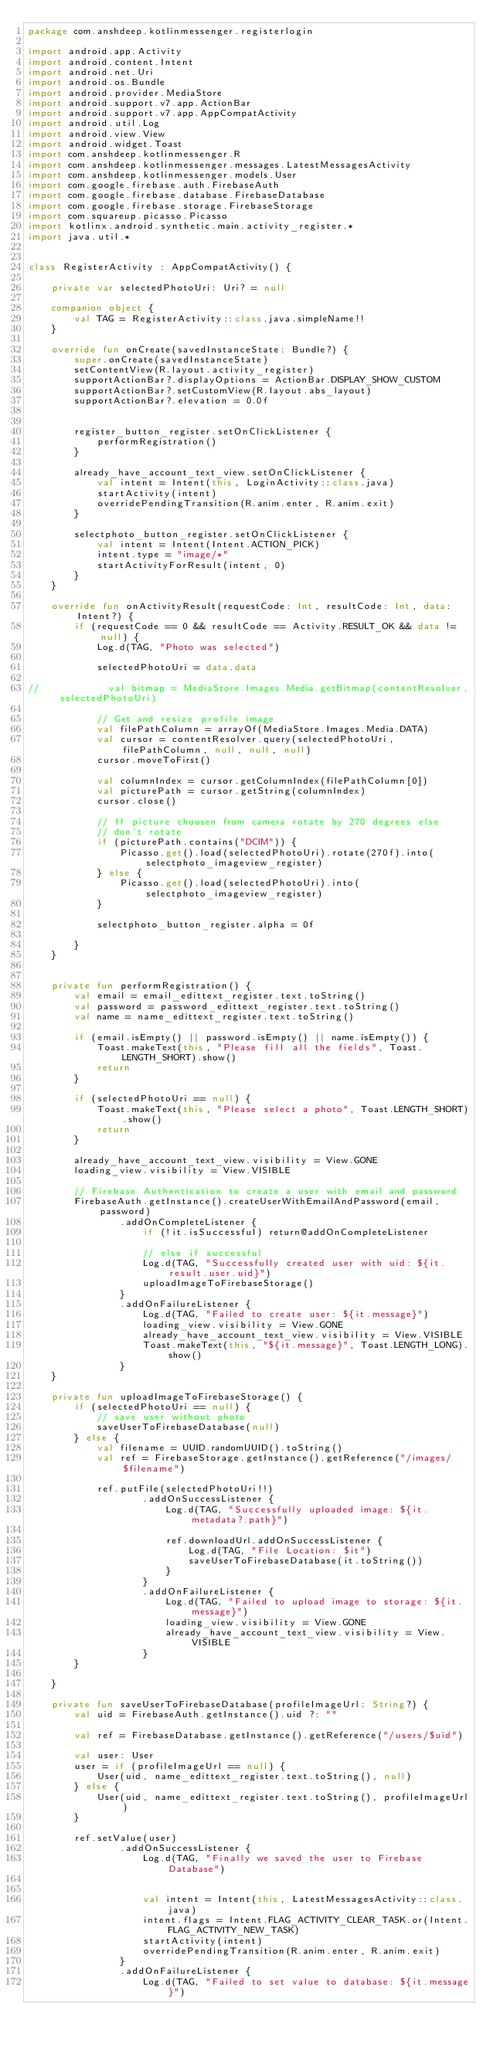<code> <loc_0><loc_0><loc_500><loc_500><_Kotlin_>package com.anshdeep.kotlinmessenger.registerlogin

import android.app.Activity
import android.content.Intent
import android.net.Uri
import android.os.Bundle
import android.provider.MediaStore
import android.support.v7.app.ActionBar
import android.support.v7.app.AppCompatActivity
import android.util.Log
import android.view.View
import android.widget.Toast
import com.anshdeep.kotlinmessenger.R
import com.anshdeep.kotlinmessenger.messages.LatestMessagesActivity
import com.anshdeep.kotlinmessenger.models.User
import com.google.firebase.auth.FirebaseAuth
import com.google.firebase.database.FirebaseDatabase
import com.google.firebase.storage.FirebaseStorage
import com.squareup.picasso.Picasso
import kotlinx.android.synthetic.main.activity_register.*
import java.util.*


class RegisterActivity : AppCompatActivity() {

    private var selectedPhotoUri: Uri? = null

    companion object {
        val TAG = RegisterActivity::class.java.simpleName!!
    }

    override fun onCreate(savedInstanceState: Bundle?) {
        super.onCreate(savedInstanceState)
        setContentView(R.layout.activity_register)
        supportActionBar?.displayOptions = ActionBar.DISPLAY_SHOW_CUSTOM
        supportActionBar?.setCustomView(R.layout.abs_layout)
        supportActionBar?.elevation = 0.0f


        register_button_register.setOnClickListener {
            performRegistration()
        }

        already_have_account_text_view.setOnClickListener {
            val intent = Intent(this, LoginActivity::class.java)
            startActivity(intent)
            overridePendingTransition(R.anim.enter, R.anim.exit)
        }

        selectphoto_button_register.setOnClickListener {
            val intent = Intent(Intent.ACTION_PICK)
            intent.type = "image/*"
            startActivityForResult(intent, 0)
        }
    }

    override fun onActivityResult(requestCode: Int, resultCode: Int, data: Intent?) {
        if (requestCode == 0 && resultCode == Activity.RESULT_OK && data != null) {
            Log.d(TAG, "Photo was selected")

            selectedPhotoUri = data.data

//            val bitmap = MediaStore.Images.Media.getBitmap(contentResolver, selectedPhotoUri)

            // Get and resize profile image
            val filePathColumn = arrayOf(MediaStore.Images.Media.DATA)
            val cursor = contentResolver.query(selectedPhotoUri, filePathColumn, null, null, null)
            cursor.moveToFirst()

            val columnIndex = cursor.getColumnIndex(filePathColumn[0])
            val picturePath = cursor.getString(columnIndex)
            cursor.close()

            // If picture choosen from camera rotate by 270 degrees else
            // don't rotate
            if (picturePath.contains("DCIM")) {
                Picasso.get().load(selectedPhotoUri).rotate(270f).into(selectphoto_imageview_register)
            } else {
                Picasso.get().load(selectedPhotoUri).into(selectphoto_imageview_register)
            }

            selectphoto_button_register.alpha = 0f

        }
    }


    private fun performRegistration() {
        val email = email_edittext_register.text.toString()
        val password = password_edittext_register.text.toString()
        val name = name_edittext_register.text.toString()

        if (email.isEmpty() || password.isEmpty() || name.isEmpty()) {
            Toast.makeText(this, "Please fill all the fields", Toast.LENGTH_SHORT).show()
            return
        }

        if (selectedPhotoUri == null) {
            Toast.makeText(this, "Please select a photo", Toast.LENGTH_SHORT).show()
            return
        }

        already_have_account_text_view.visibility = View.GONE
        loading_view.visibility = View.VISIBLE

        // Firebase Authentication to create a user with email and password
        FirebaseAuth.getInstance().createUserWithEmailAndPassword(email, password)
                .addOnCompleteListener {
                    if (!it.isSuccessful) return@addOnCompleteListener

                    // else if successful
                    Log.d(TAG, "Successfully created user with uid: ${it.result.user.uid}")
                    uploadImageToFirebaseStorage()
                }
                .addOnFailureListener {
                    Log.d(TAG, "Failed to create user: ${it.message}")
                    loading_view.visibility = View.GONE
                    already_have_account_text_view.visibility = View.VISIBLE
                    Toast.makeText(this, "${it.message}", Toast.LENGTH_LONG).show()
                }
    }

    private fun uploadImageToFirebaseStorage() {
        if (selectedPhotoUri == null) {
            // save user without photo
            saveUserToFirebaseDatabase(null)
        } else {
            val filename = UUID.randomUUID().toString()
            val ref = FirebaseStorage.getInstance().getReference("/images/$filename")

            ref.putFile(selectedPhotoUri!!)
                    .addOnSuccessListener {
                        Log.d(TAG, "Successfully uploaded image: ${it.metadata?.path}")

                        ref.downloadUrl.addOnSuccessListener {
                            Log.d(TAG, "File Location: $it")
                            saveUserToFirebaseDatabase(it.toString())
                        }
                    }
                    .addOnFailureListener {
                        Log.d(TAG, "Failed to upload image to storage: ${it.message}")
                        loading_view.visibility = View.GONE
                        already_have_account_text_view.visibility = View.VISIBLE
                    }
        }

    }

    private fun saveUserToFirebaseDatabase(profileImageUrl: String?) {
        val uid = FirebaseAuth.getInstance().uid ?: ""

        val ref = FirebaseDatabase.getInstance().getReference("/users/$uid")

        val user: User
        user = if (profileImageUrl == null) {
            User(uid, name_edittext_register.text.toString(), null)
        } else {
            User(uid, name_edittext_register.text.toString(), profileImageUrl)
        }

        ref.setValue(user)
                .addOnSuccessListener {
                    Log.d(TAG, "Finally we saved the user to Firebase Database")


                    val intent = Intent(this, LatestMessagesActivity::class.java)
                    intent.flags = Intent.FLAG_ACTIVITY_CLEAR_TASK.or(Intent.FLAG_ACTIVITY_NEW_TASK)
                    startActivity(intent)
                    overridePendingTransition(R.anim.enter, R.anim.exit)
                }
                .addOnFailureListener {
                    Log.d(TAG, "Failed to set value to database: ${it.message}")</code> 